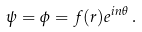<formula> <loc_0><loc_0><loc_500><loc_500>\psi = \phi = f ( r ) e ^ { i n \theta } \, .</formula> 